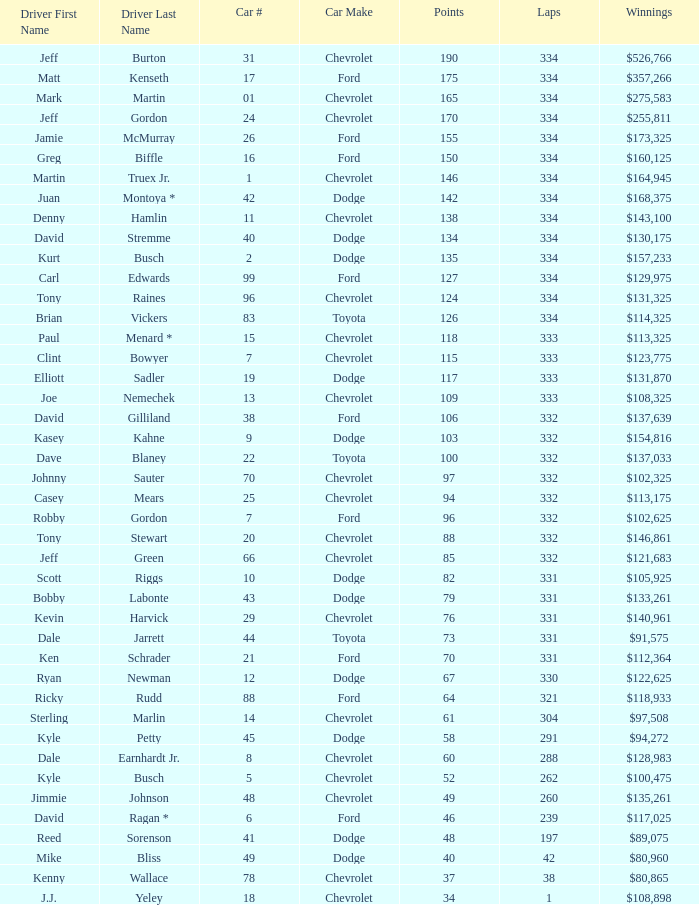How many total laps did the Chevrolet that won $97,508 make? 1.0. 